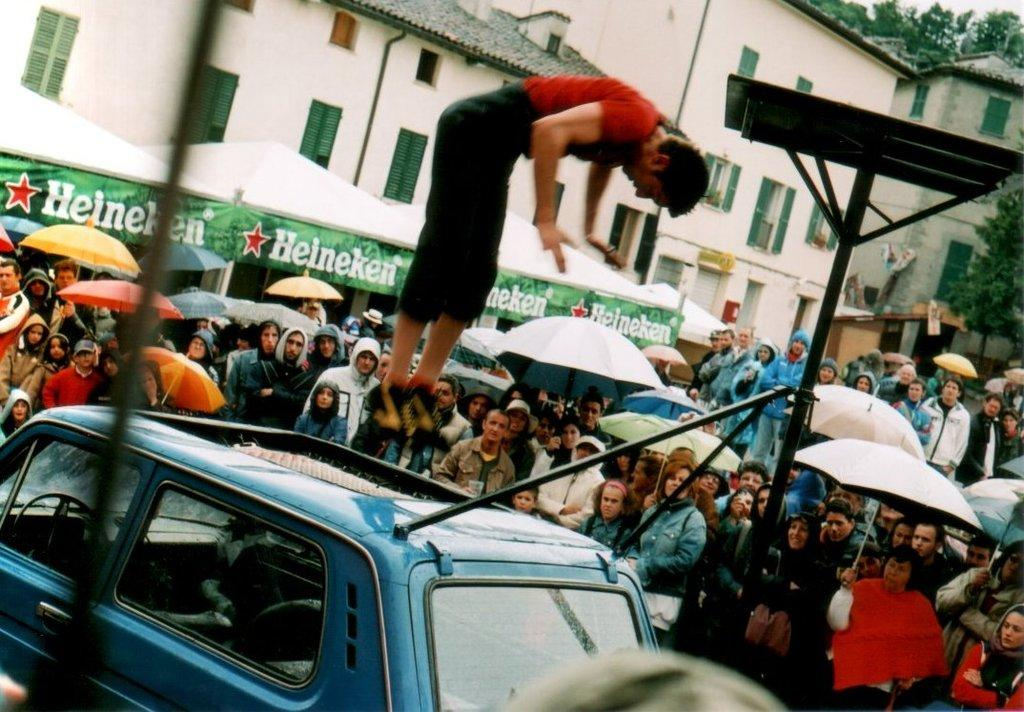<image>
Describe the image concisely. A person jumping on top of a car in front of a long green banner with the brand Heineken on it. 